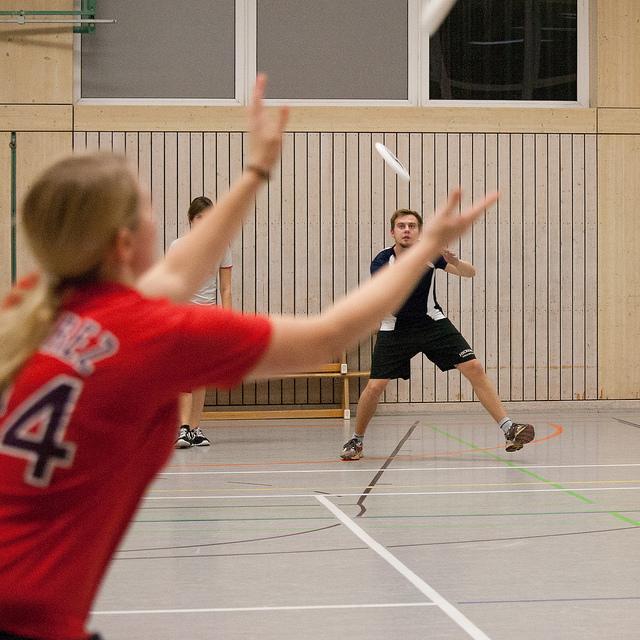What is reflected in the window in the upper corner?
Give a very brief answer. Window. Are they indoors?
Quick response, please. Yes. How many windows are shown?
Concise answer only. 3. 